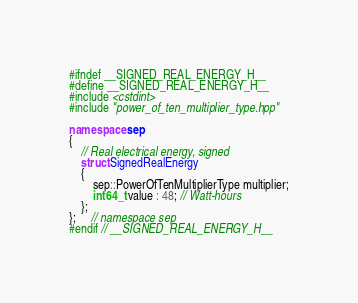<code> <loc_0><loc_0><loc_500><loc_500><_C++_>#ifndef __SIGNED_REAL_ENERGY_H__
#define __SIGNED_REAL_ENERGY_H__
#include <cstdint>
#include "power_of_ten_multiplier_type.hpp"

namespace sep
{
    // Real electrical energy, signed
    struct SignedRealEnergy
    {
        sep::PowerOfTenMultiplierType multiplier;
        int64_t value : 48; // Watt-hours
    };
};     // namespace sep
#endif // __SIGNED_REAL_ENERGY_H__</code> 